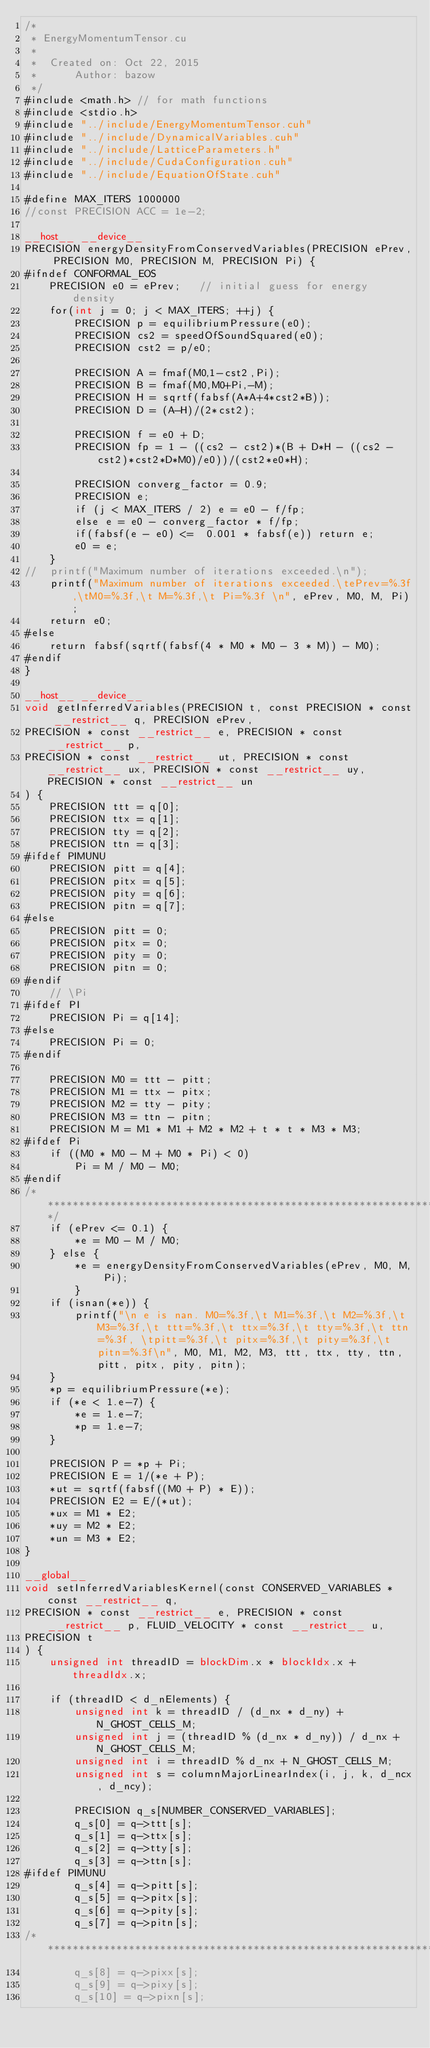Convert code to text. <code><loc_0><loc_0><loc_500><loc_500><_Cuda_>/*
 * EnergyMomentumTensor.cu
 *
 *  Created on: Oct 22, 2015
 *      Author: bazow
 */
#include <math.h> // for math functions
#include <stdio.h>
#include "../include/EnergyMomentumTensor.cuh"
#include "../include/DynamicalVariables.cuh"
#include "../include/LatticeParameters.h"
#include "../include/CudaConfiguration.cuh"
#include "../include/EquationOfState.cuh"

#define MAX_ITERS 1000000
//const PRECISION ACC = 1e-2;

__host__ __device__
PRECISION energyDensityFromConservedVariables(PRECISION ePrev, PRECISION M0, PRECISION M, PRECISION Pi) {
#ifndef CONFORMAL_EOS
	PRECISION e0 = ePrev;	// initial guess for energy density
	for(int j = 0; j < MAX_ITERS; ++j) {
		PRECISION p = equilibriumPressure(e0);
		PRECISION cs2 = speedOfSoundSquared(e0);
		PRECISION cst2 = p/e0;

		PRECISION A = fmaf(M0,1-cst2,Pi);
		PRECISION B = fmaf(M0,M0+Pi,-M);
		PRECISION H = sqrtf(fabsf(A*A+4*cst2*B));
		PRECISION D = (A-H)/(2*cst2);

		PRECISION f = e0 + D;
		PRECISION fp = 1 - ((cs2 - cst2)*(B + D*H - ((cs2 - cst2)*cst2*D*M0)/e0))/(cst2*e0*H);

		PRECISION converg_factor = 0.9;
		PRECISION e;
		if (j < MAX_ITERS / 2) e = e0 - f/fp;
		else e = e0 - converg_factor * f/fp;
		if(fabsf(e - e0) <=  0.001 * fabsf(e)) return e;
		e0 = e;
	}
//	printf("Maximum number of iterations exceeded.\n");
	printf("Maximum number of iterations exceeded.\tePrev=%.3f,\tM0=%.3f,\t M=%.3f,\t Pi=%.3f \n", ePrev, M0, M, Pi);
	return e0;
#else
	return fabsf(sqrtf(fabsf(4 * M0 * M0 - 3 * M)) - M0);
#endif
}

__host__ __device__
void getInferredVariables(PRECISION t, const PRECISION * const __restrict__ q, PRECISION ePrev,
PRECISION * const __restrict__ e, PRECISION * const __restrict__ p,
PRECISION * const __restrict__ ut, PRECISION * const __restrict__ ux, PRECISION * const __restrict__ uy, PRECISION * const __restrict__ un
) {
	PRECISION ttt = q[0];
	PRECISION ttx = q[1];
	PRECISION tty = q[2];
	PRECISION ttn = q[3];
#ifdef PIMUNU
	PRECISION pitt = q[4];
	PRECISION pitx = q[5];
	PRECISION pity = q[6];
	PRECISION pitn = q[7];
#else
	PRECISION pitt = 0;
	PRECISION pitx = 0;
	PRECISION pity = 0;
	PRECISION pitn = 0;
#endif
	// \Pi
#ifdef PI
	PRECISION Pi = q[14];
#else
	PRECISION Pi = 0;
#endif

	PRECISION M0 = ttt - pitt;
	PRECISION M1 = ttx - pitx;
	PRECISION M2 = tty - pity;
	PRECISION M3 = ttn - pitn;
	PRECISION M = M1 * M1 + M2 * M2 + t * t * M3 * M3;
#ifdef Pi
	if ((M0 * M0 - M + M0 * Pi) < 0)
		Pi = M / M0 - M0;
#endif
/****************************************************************************/
	if (ePrev <= 0.1) {
		*e = M0 - M / M0;
	} else {
		*e = energyDensityFromConservedVariables(ePrev, M0, M, Pi);
		}
	if (isnan(*e)) {
		printf("\n e is nan. M0=%.3f,\t M1=%.3f,\t M2=%.3f,\t M3=%.3f,\t ttt=%.3f,\t ttx=%.3f,\t tty=%.3f,\t ttn=%.3f, \tpitt=%.3f,\t pitx=%.3f,\t pity=%.3f,\t pitn=%.3f\n", M0, M1, M2, M3, ttt, ttx, tty, ttn, pitt, pitx, pity, pitn);
	}
	*p = equilibriumPressure(*e);
	if (*e < 1.e-7) {
		*e = 1.e-7;
		*p = 1.e-7;
	}

	PRECISION P = *p + Pi;
	PRECISION E = 1/(*e + P);
	*ut = sqrtf(fabsf((M0 + P) * E));
	PRECISION E2 = E/(*ut);
	*ux = M1 * E2;
	*uy = M2 * E2;
	*un = M3 * E2;
}

__global__
void setInferredVariablesKernel(const CONSERVED_VARIABLES * const __restrict__ q,
PRECISION * const __restrict__ e, PRECISION * const __restrict__ p, FLUID_VELOCITY * const __restrict__ u,
PRECISION t
) {
	unsigned int threadID = blockDim.x * blockIdx.x + threadIdx.x;

	if (threadID < d_nElements) {
		unsigned int k = threadID / (d_nx * d_ny) + N_GHOST_CELLS_M;
		unsigned int j = (threadID % (d_nx * d_ny)) / d_nx + N_GHOST_CELLS_M;
		unsigned int i = threadID % d_nx + N_GHOST_CELLS_M;
		unsigned int s = columnMajorLinearIndex(i, j, k, d_ncx, d_ncy);

		PRECISION q_s[NUMBER_CONSERVED_VARIABLES];
		q_s[0] = q->ttt[s];
		q_s[1] = q->ttx[s];
		q_s[2] = q->tty[s];
		q_s[3] = q->ttn[s];
#ifdef PIMUNU
		q_s[4] = q->pitt[s];
		q_s[5] = q->pitx[s];
		q_s[6] = q->pity[s];
		q_s[7] = q->pitn[s];
/****************************************************************************\
		q_s[8] = q->pixx[s];
		q_s[9] = q->pixy[s];
		q_s[10] = q->pixn[s];</code> 